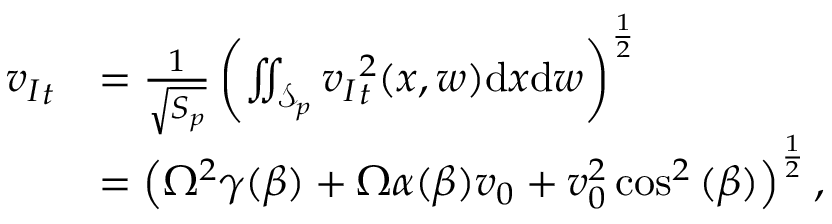<formula> <loc_0><loc_0><loc_500><loc_500>\begin{array} { r l } { { v _ { I } } _ { t } } & { = \frac { 1 } { \sqrt { S _ { p } } } \left ( \iint _ { \mathcal { S } _ { p } } { v _ { I } } _ { t } ^ { 2 } ( x , w ) d x d w \right ) ^ { \frac { 1 } { 2 } } } \\ & { = \left ( \Omega ^ { 2 } \gamma ( \beta ) + \Omega \alpha ( \beta ) v _ { 0 } + v _ { 0 } ^ { 2 } \cos ^ { 2 } { ( \beta ) } \right ) ^ { \frac { 1 } { 2 } } , } \end{array}</formula> 